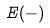<formula> <loc_0><loc_0><loc_500><loc_500>E ( - )</formula> 